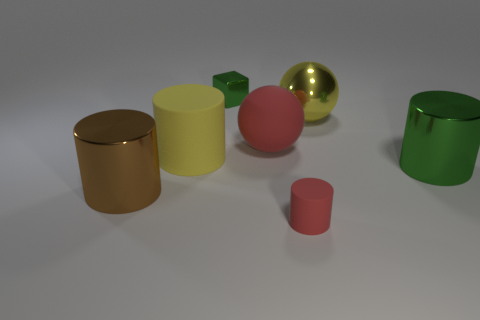Is there any object that stands out due to its unique shape? Yes, the green block on the far right stands out because it has a distinct rectangular prism shape, unlike the other cylindrical and spherical objects. What does the arrangement of objects convey? The arrangement of the objects appears random but could imply a study in geometric forms and contrasting colors, likely for an aesthetic or educational purpose. 